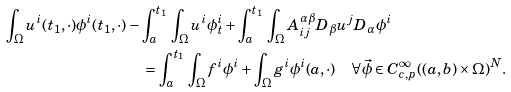<formula> <loc_0><loc_0><loc_500><loc_500>\int _ { \Omega } u ^ { i } ( t _ { 1 } , \cdot ) \phi ^ { i } ( t _ { 1 } , \cdot ) & - \int _ { a } ^ { t _ { 1 } } \, \int _ { \Omega } u ^ { i } \phi ^ { i } _ { t } + \int _ { a } ^ { t _ { 1 } } \, \int _ { \Omega } A ^ { \alpha \beta } _ { i j } D _ { \beta } u ^ { j } D _ { \alpha } \phi ^ { i } \\ & \quad = \int _ { a } ^ { t _ { 1 } } \, \int _ { \Omega } f ^ { i } \phi ^ { i } + \int _ { \Omega } g ^ { i } \phi ^ { i } ( a , \cdot ) \quad \forall \vec { \phi } \in C ^ { \infty } _ { c , p } ( ( a , b ) \times \Omega ) ^ { N } .</formula> 